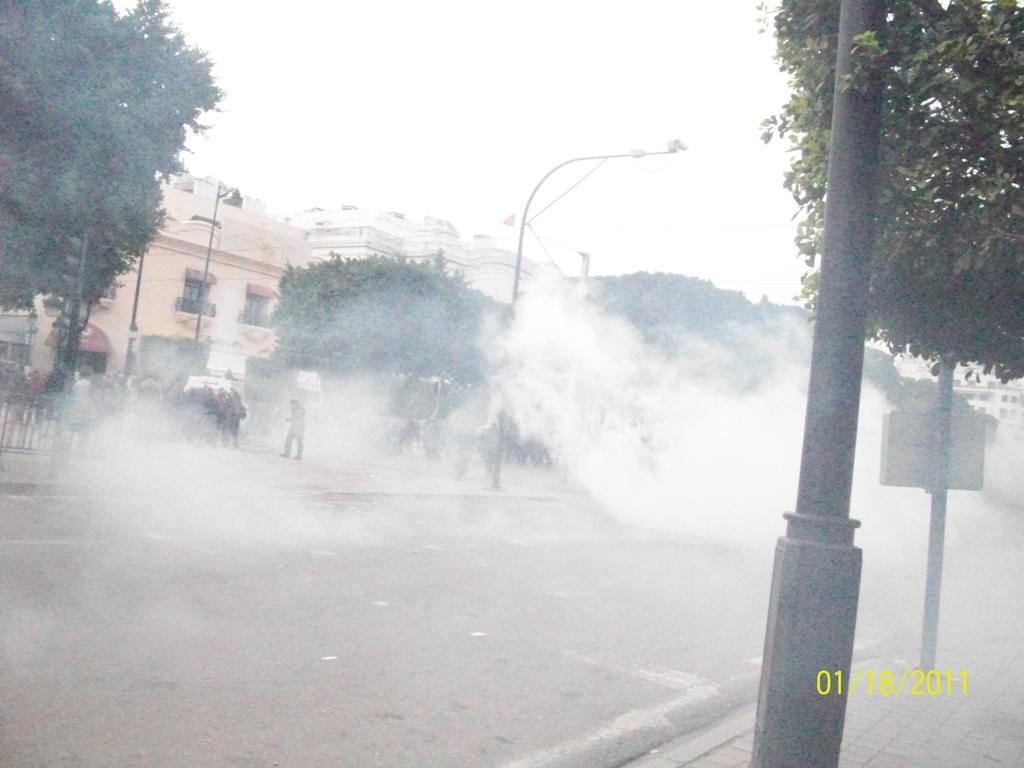In one or two sentences, can you explain what this image depicts? In the foreground of this picture, we can see the smoke on the road. On the right side of this image, there is a pole, tree, and a side path. In the background, we can see trees, poles, buildings, railing, signal pole and the sky. 